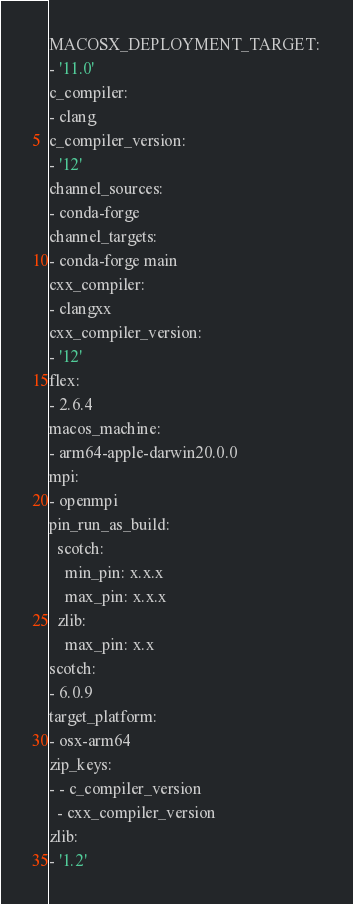Convert code to text. <code><loc_0><loc_0><loc_500><loc_500><_YAML_>MACOSX_DEPLOYMENT_TARGET:
- '11.0'
c_compiler:
- clang
c_compiler_version:
- '12'
channel_sources:
- conda-forge
channel_targets:
- conda-forge main
cxx_compiler:
- clangxx
cxx_compiler_version:
- '12'
flex:
- 2.6.4
macos_machine:
- arm64-apple-darwin20.0.0
mpi:
- openmpi
pin_run_as_build:
  scotch:
    min_pin: x.x.x
    max_pin: x.x.x
  zlib:
    max_pin: x.x
scotch:
- 6.0.9
target_platform:
- osx-arm64
zip_keys:
- - c_compiler_version
  - cxx_compiler_version
zlib:
- '1.2'
</code> 